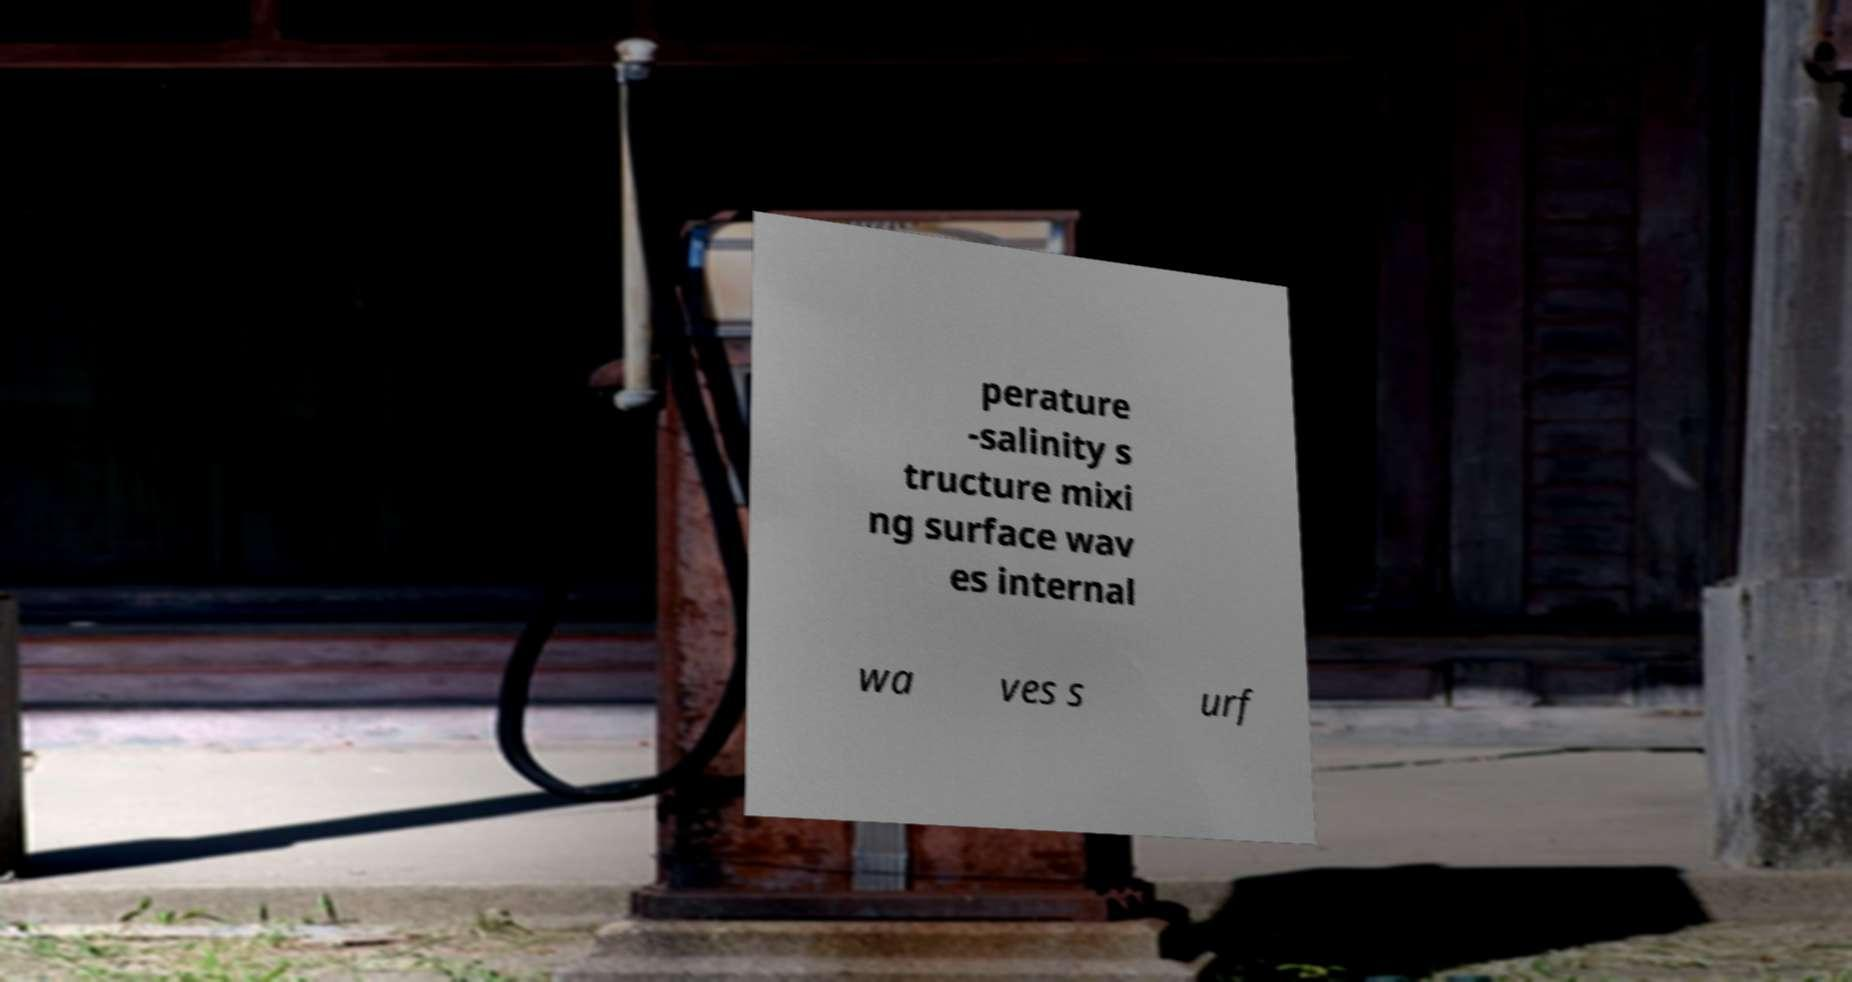Can you accurately transcribe the text from the provided image for me? perature -salinity s tructure mixi ng surface wav es internal wa ves s urf 